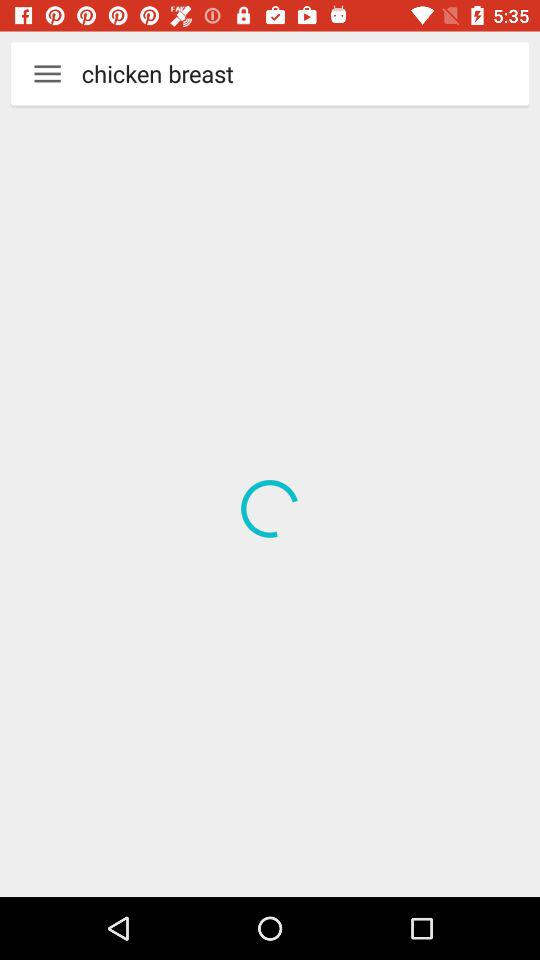What is the time duration for making "The Cake Doctor's Red Velvet Cake"? The time duration for making "The Cake Doctor's Red Velvet Cake" is 41 minutes. 